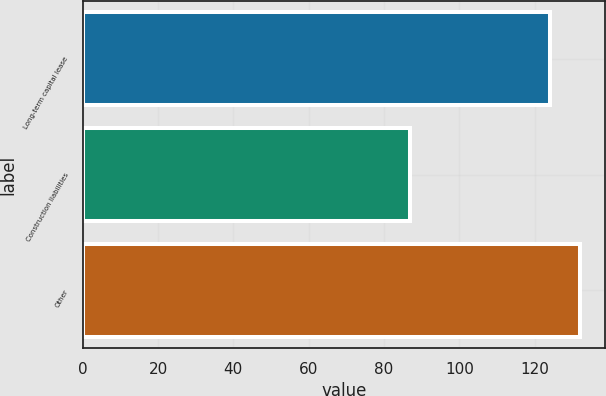Convert chart. <chart><loc_0><loc_0><loc_500><loc_500><bar_chart><fcel>Long-term capital lease<fcel>Construction liabilities<fcel>Other<nl><fcel>124<fcel>87<fcel>132<nl></chart> 